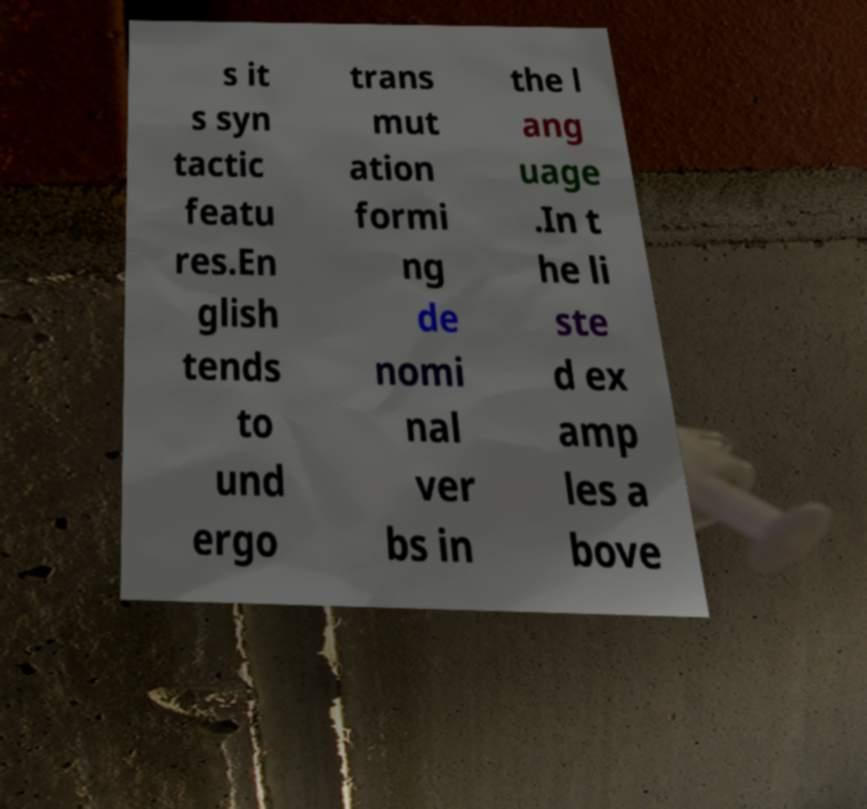Could you assist in decoding the text presented in this image and type it out clearly? s it s syn tactic featu res.En glish tends to und ergo trans mut ation formi ng de nomi nal ver bs in the l ang uage .In t he li ste d ex amp les a bove 